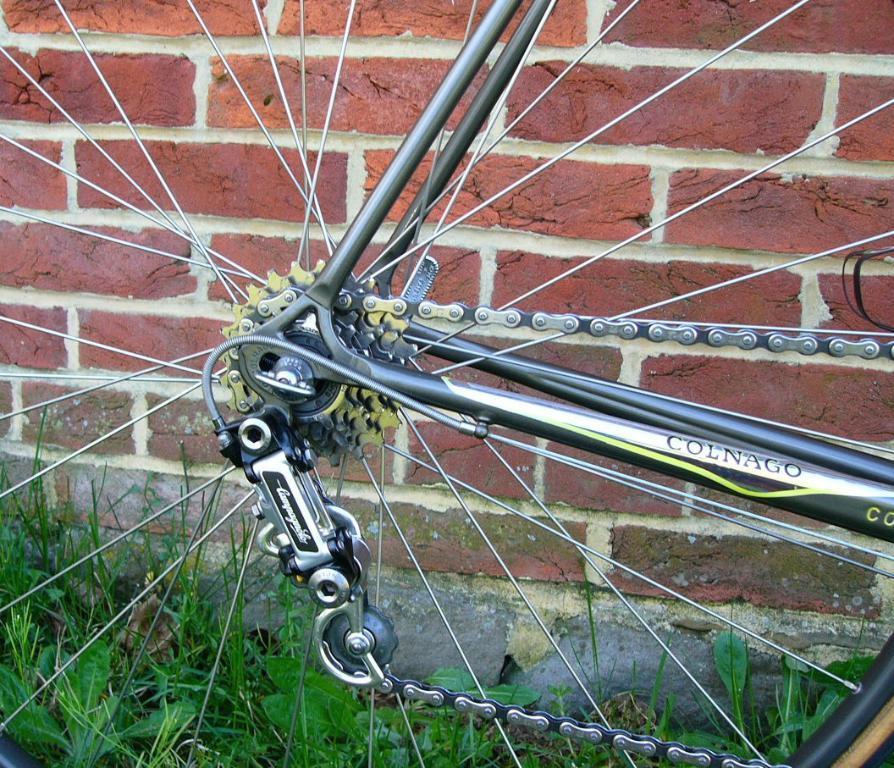Please provide a concise description of this image. In this picture I can see a bicycle wheel and I can see few plants on the ground and a brick wall. 